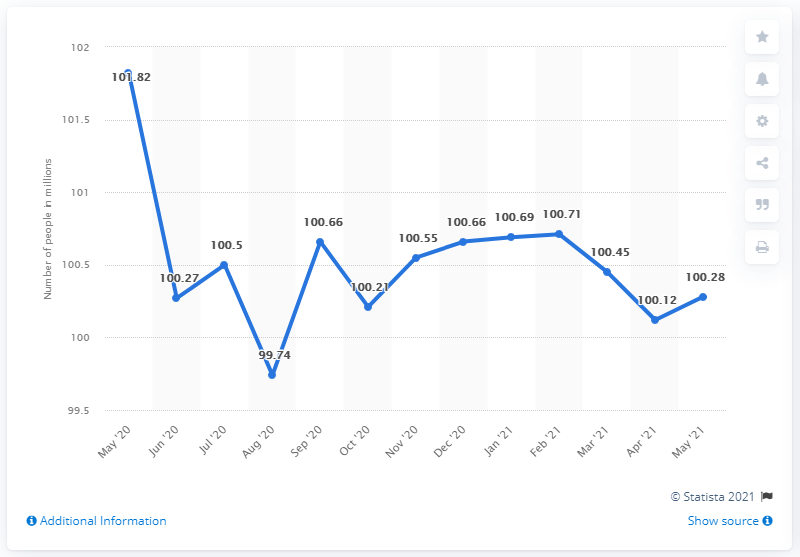Could you explain the trend in the inactive labor force from January to May 2021? Certainly! From January to May 2021, the number started at around 100.21 million, peaked in February at 100.66 million, slightly declined to about 100.55 million in March, and reduced to around 100.45 million in April before slightly rising again to approximately 100.28 million in May. 